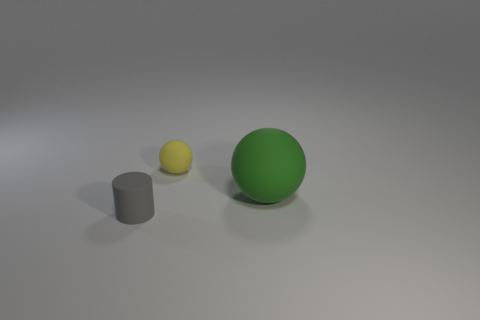Add 1 big brown balls. How many objects exist? 4 Subtract all cylinders. How many objects are left? 2 Add 1 gray objects. How many gray objects are left? 2 Add 1 yellow rubber balls. How many yellow rubber balls exist? 2 Subtract 0 blue cylinders. How many objects are left? 3 Subtract all large brown matte objects. Subtract all small yellow spheres. How many objects are left? 2 